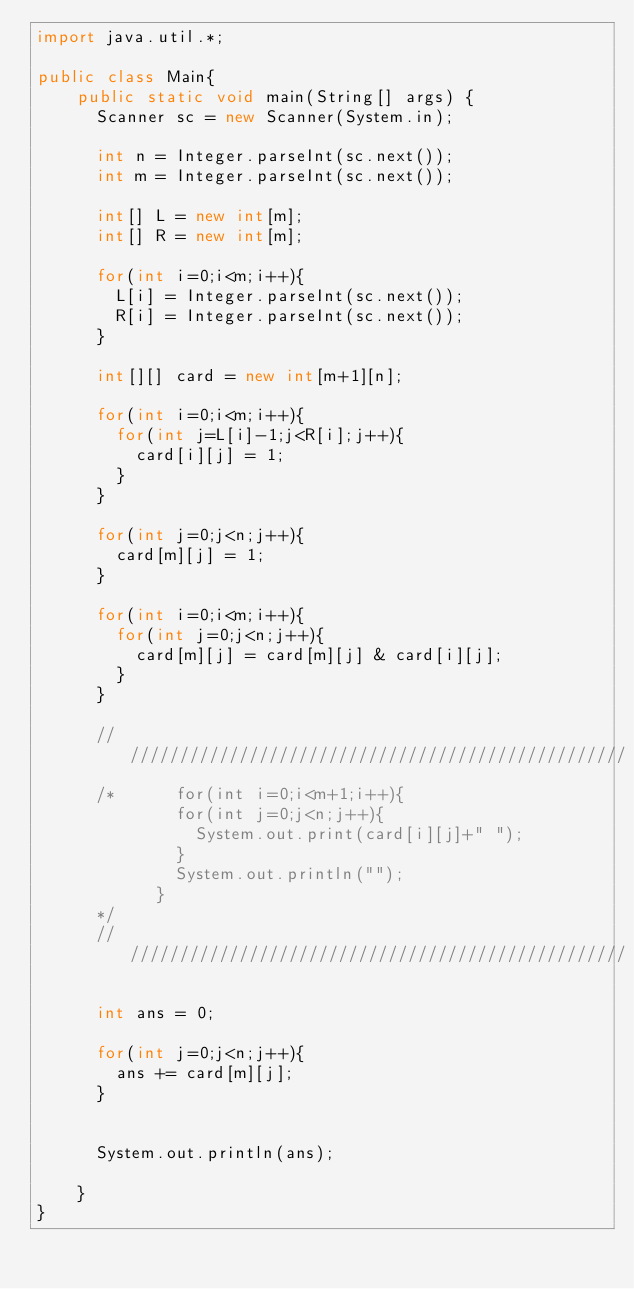Convert code to text. <code><loc_0><loc_0><loc_500><loc_500><_Java_>import java.util.*;

public class Main{
    public static void main(String[] args) {
      Scanner sc = new Scanner(System.in);

      int n = Integer.parseInt(sc.next());
      int m = Integer.parseInt(sc.next());

      int[] L = new int[m];
      int[] R = new int[m];

      for(int i=0;i<m;i++){
        L[i] = Integer.parseInt(sc.next());
        R[i] = Integer.parseInt(sc.next());
      }

      int[][] card = new int[m+1][n];

      for(int i=0;i<m;i++){
        for(int j=L[i]-1;j<R[i];j++){
          card[i][j] = 1;
        }
      }

      for(int j=0;j<n;j++){
        card[m][j] = 1;
      }

      for(int i=0;i<m;i++){
        for(int j=0;j<n;j++){
          card[m][j] = card[m][j] & card[i][j];
        }
      }

      ////////////////////////////////////////////////////
      /*      for(int i=0;i<m+1;i++){
              for(int j=0;j<n;j++){
                System.out.print(card[i][j]+" ");
              }
              System.out.println("");
            }
      */
      ////////////////////////////////////////////////////

      int ans = 0;

      for(int j=0;j<n;j++){
        ans += card[m][j];
      }


      System.out.println(ans);

    }
}
</code> 